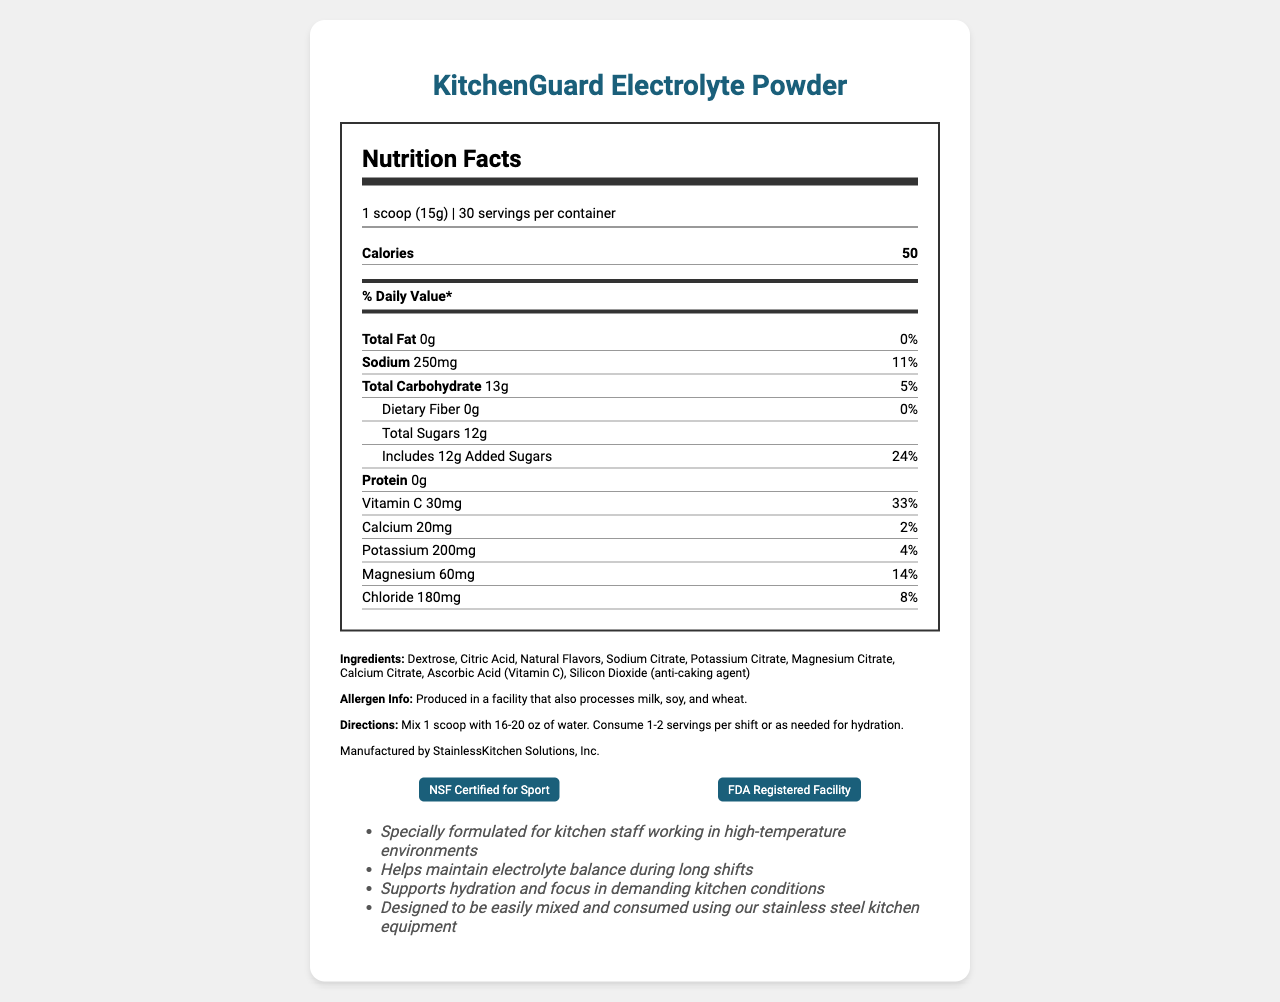what is the serving size? The serving size is listed as "1 scoop (15g)" at the top of the document.
Answer: 1 scoop (15g) how many servings are in the container? The number of servings per container is 30, as stated in the document.
Answer: 30 how many calories are there per serving? The document indicates there are 50 calories per serving.
Answer: 50 how much sodium does each serving contain? Each serving contains 250mg of sodium, as per the document.
Answer: 250mg what is the daily value percentage of vitamin C per serving? The document shows that each serving contains 30mg of vitamin C, which is 33% of the daily value.
Answer: 33% which of the following nutrients has the highest daily value percentage in one serving? A. Sodium B. Vitamin C C. Magnesium D. Calcium Vitamin C has a daily value of 33%, which is the highest among the given options.
Answer: B which ingredient is used as an anti-caking agent? A. Citric Acid B. Silicon Dioxide C. Sodium Citrate D. Ascorbic Acid Silicon Dioxide is listed as the anti-caking agent in the ingredient list.
Answer: B is this product free from any allergens? The allergen info states that it is produced in a facility that also processes milk, soy, and wheat.
Answer: No summarize the main purpose of this document. The summary captures the primary content and purpose of the document, which is to present the nutritional information and benefits of the KitchenGuard Electrolyte Powder.
Answer: The document provides nutrition facts and product information for KitchenGuard Electrolyte Powder, a fortified hydration supplement specifically designed for kitchen staff working in high-temperature environments. It includes ingredient details, nutritional values, certification info, and directions for use. can we determine the exact manufacturing date of the product from the document? The document does not provide any information regarding the manufacturing date of the product.
Answer: Cannot be determined 